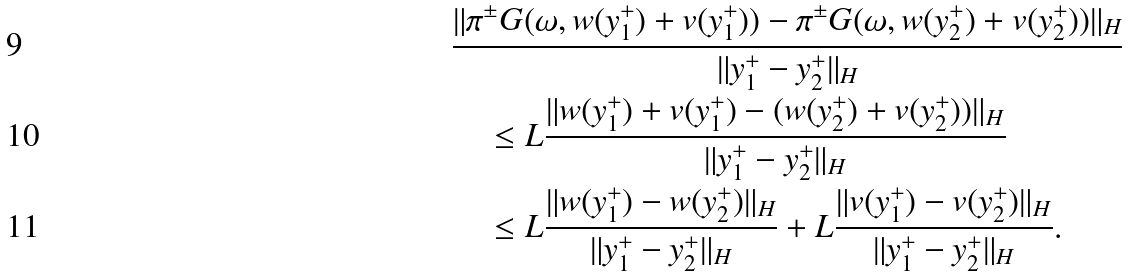Convert formula to latex. <formula><loc_0><loc_0><loc_500><loc_500>& \frac { \| \pi ^ { \pm } G ( \omega , w ( y _ { 1 } ^ { + } ) + v ( y _ { 1 } ^ { + } ) ) - \pi ^ { \pm } G ( \omega , w ( y _ { 2 } ^ { + } ) + v ( y _ { 2 } ^ { + } ) ) \| _ { H } } { \| y _ { 1 } ^ { + } - y _ { 2 } ^ { + } \| _ { H } } \\ & \quad \leq L \frac { \| w ( y _ { 1 } ^ { + } ) + v ( y _ { 1 } ^ { + } ) - ( w ( y _ { 2 } ^ { + } ) + v ( y _ { 2 } ^ { + } ) ) \| _ { H } } { \| y _ { 1 } ^ { + } - y _ { 2 } ^ { + } \| _ { H } } \\ & \quad \leq L \frac { \| w ( y _ { 1 } ^ { + } ) - w ( y _ { 2 } ^ { + } ) \| _ { H } } { \| y _ { 1 } ^ { + } - y _ { 2 } ^ { + } \| _ { H } } + L \frac { \| v ( y _ { 1 } ^ { + } ) - v ( y _ { 2 } ^ { + } ) \| _ { H } } { \| y _ { 1 } ^ { + } - y _ { 2 } ^ { + } \| _ { H } } .</formula> 